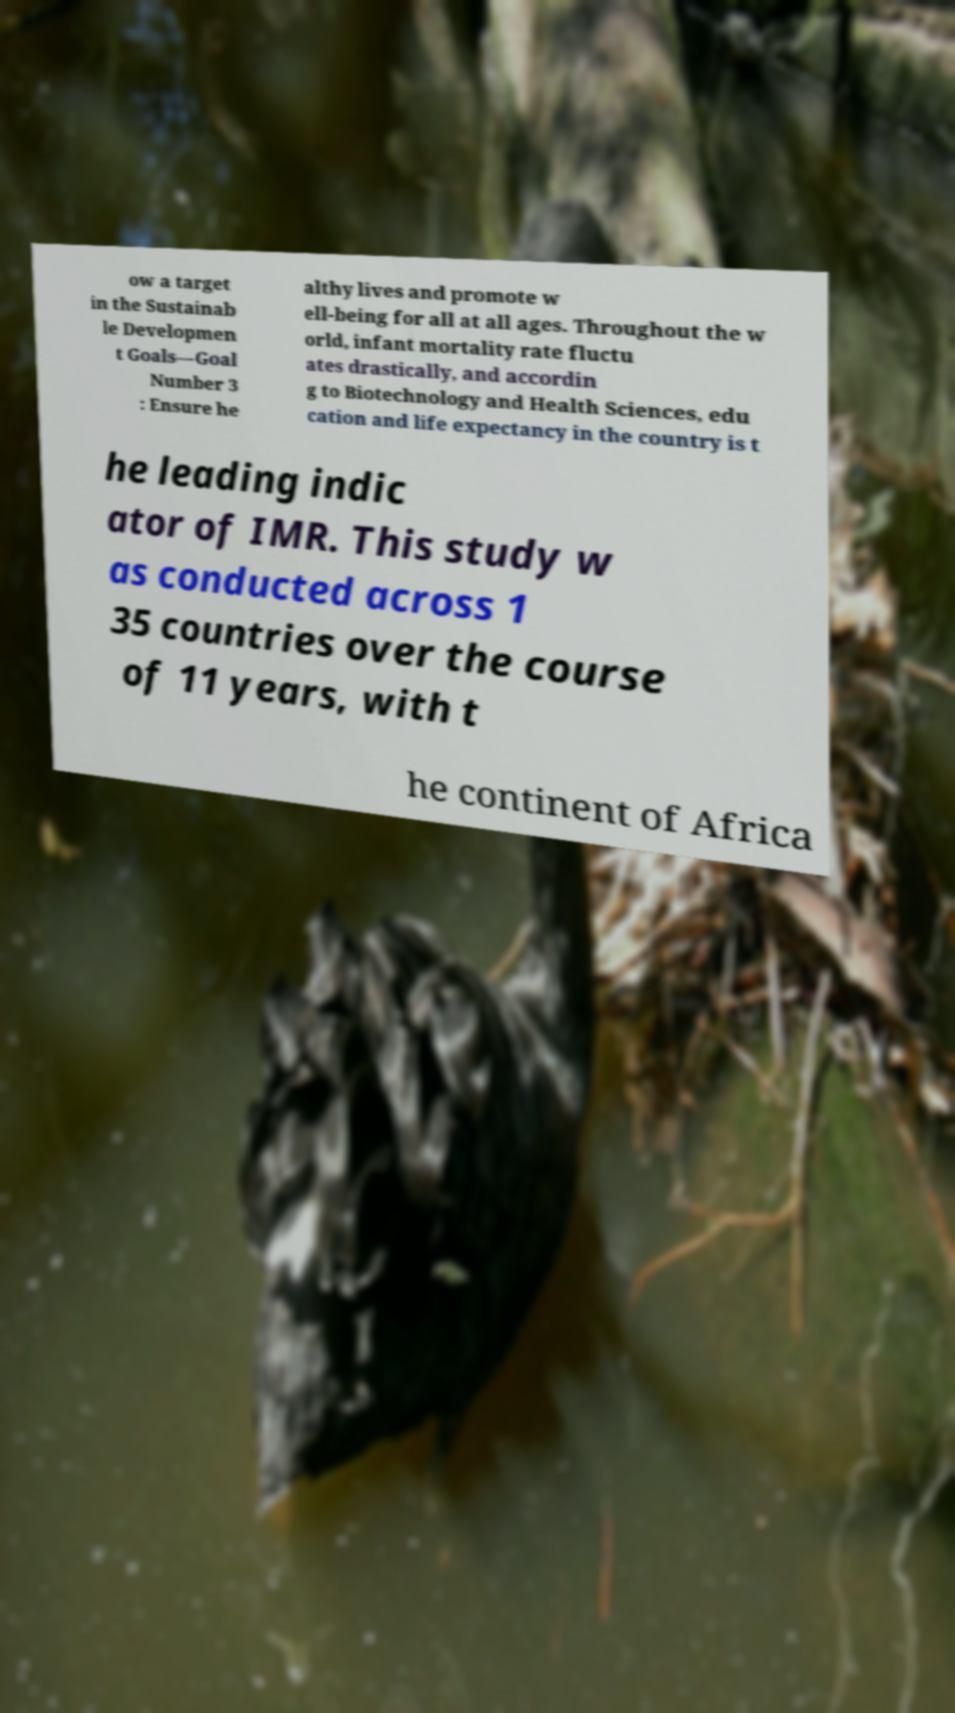What messages or text are displayed in this image? I need them in a readable, typed format. ow a target in the Sustainab le Developmen t Goals—Goal Number 3 : Ensure he althy lives and promote w ell-being for all at all ages. Throughout the w orld, infant mortality rate fluctu ates drastically, and accordin g to Biotechnology and Health Sciences, edu cation and life expectancy in the country is t he leading indic ator of IMR. This study w as conducted across 1 35 countries over the course of 11 years, with t he continent of Africa 